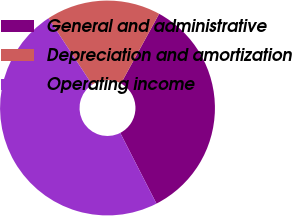<chart> <loc_0><loc_0><loc_500><loc_500><pie_chart><fcel>General and administrative<fcel>Depreciation and amortization<fcel>Operating income<nl><fcel>34.48%<fcel>17.24%<fcel>48.28%<nl></chart> 